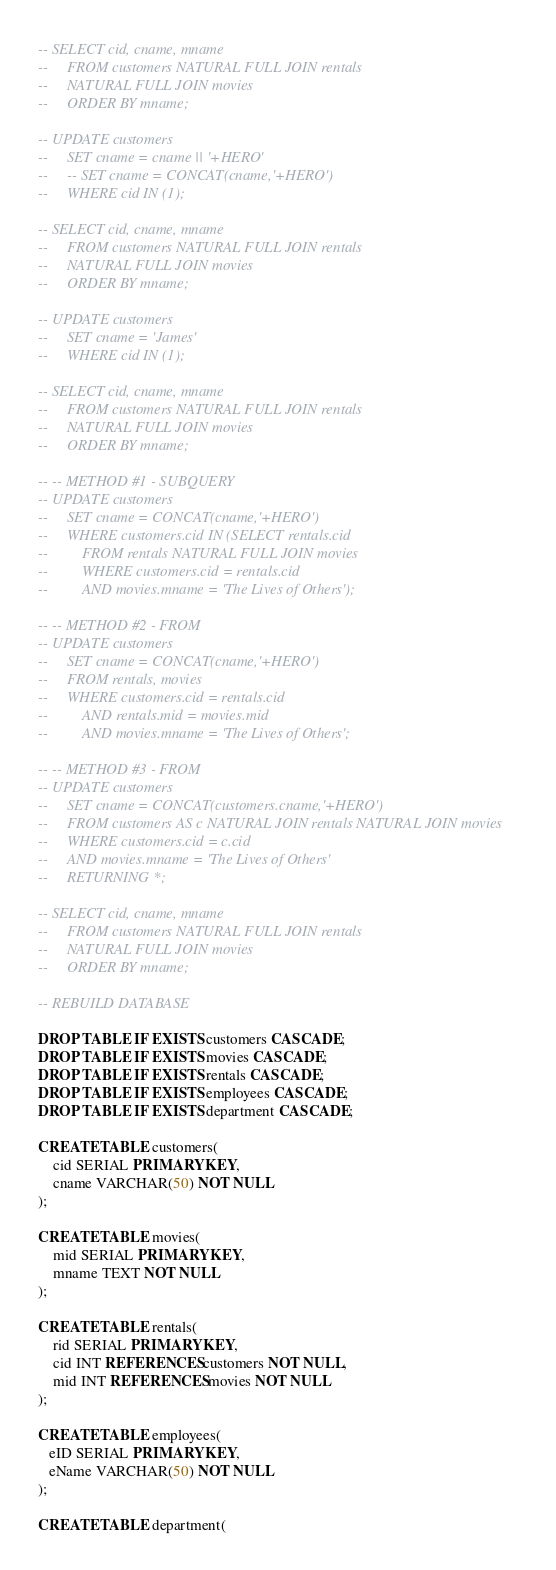<code> <loc_0><loc_0><loc_500><loc_500><_SQL_>-- SELECT cid, cname, mname 
--     FROM customers NATURAL FULL JOIN rentals
--     NATURAL FULL JOIN movies
--     ORDER BY mname;

-- UPDATE customers 
--     SET cname = cname || '+HERO'
--     -- SET cname = CONCAT(cname,'+HERO')
--     WHERE cid IN (1);

-- SELECT cid, cname, mname 
--     FROM customers NATURAL FULL JOIN rentals
--     NATURAL FULL JOIN movies
--     ORDER BY mname;

-- UPDATE customers 
--     SET cname = 'James'
--     WHERE cid IN (1);

-- SELECT cid, cname, mname 
--     FROM customers NATURAL FULL JOIN rentals
--     NATURAL FULL JOIN movies
--     ORDER BY mname;

-- -- METHOD #1 - SUBQUERY
-- UPDATE customers 
--     SET cname = CONCAT(cname,'+HERO')
--     WHERE customers.cid IN (SELECT rentals.cid 
--         FROM rentals NATURAL FULL JOIN movies
--         WHERE customers.cid = rentals.cid
--         AND movies.mname = 'The Lives of Others');
    
-- -- METHOD #2 - FROM
-- UPDATE customers
--     SET cname = CONCAT(cname,'+HERO')
--     FROM rentals, movies
--     WHERE customers.cid = rentals.cid
--         AND rentals.mid = movies.mid
--         AND movies.mname = 'The Lives of Others';

-- -- METHOD #3 - FROM
-- UPDATE customers
--     SET cname = CONCAT(customers.cname,'+HERO')
--     FROM customers AS c NATURAL JOIN rentals NATURAL JOIN movies
--     WHERE customers.cid = c.cid 
--     AND movies.mname = 'The Lives of Others' 
--     RETURNING *;    

-- SELECT cid, cname, mname 
--     FROM customers NATURAL FULL JOIN rentals
--     NATURAL FULL JOIN movies
--     ORDER BY mname;

-- REBUILD DATABASE

DROP TABLE IF EXISTS customers CASCADE;
DROP TABLE IF EXISTS movies CASCADE;
DROP TABLE IF EXISTS rentals CASCADE;
DROP TABLE IF EXISTS employees CASCADE;
DROP TABLE IF EXISTS department CASCADE;

CREATE TABLE customers(
    cid SERIAL PRIMARY KEY, 
    cname VARCHAR(50) NOT NULL
);

CREATE TABLE movies(
    mid SERIAL PRIMARY KEY, 
    mname TEXT NOT NULL 
);

CREATE TABLE rentals(
    rid SERIAL PRIMARY KEY, 
    cid INT REFERENCES customers NOT NULL, 
    mid INT REFERENCES movies NOT NULL
);

CREATE TABLE employees(
   eID SERIAL PRIMARY KEY,
   eName VARCHAR(50) NOT NULL
);

CREATE TABLE department(</code> 